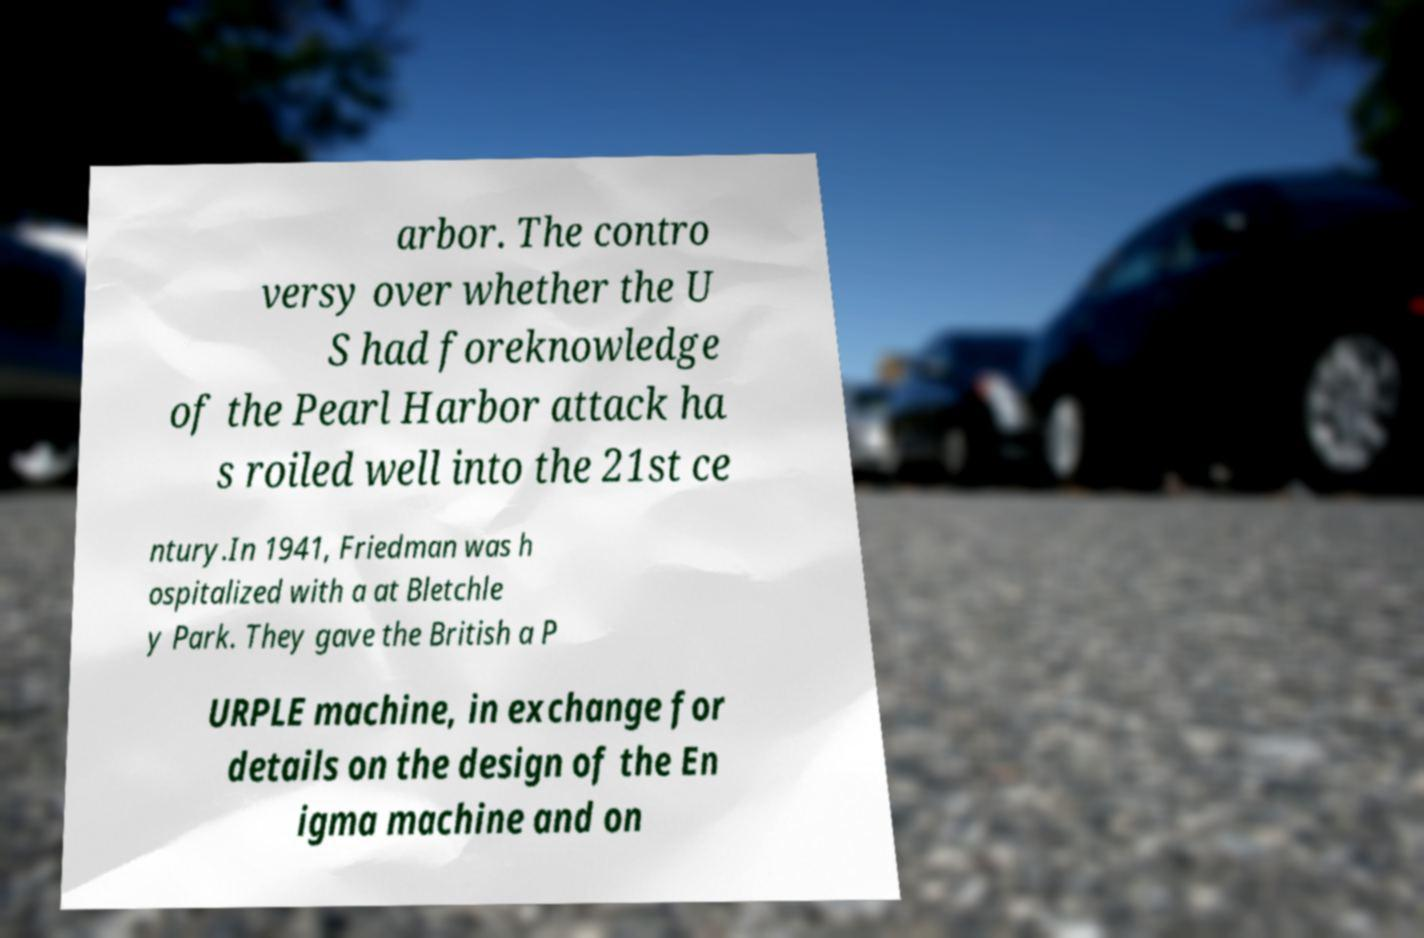Please read and relay the text visible in this image. What does it say? arbor. The contro versy over whether the U S had foreknowledge of the Pearl Harbor attack ha s roiled well into the 21st ce ntury.In 1941, Friedman was h ospitalized with a at Bletchle y Park. They gave the British a P URPLE machine, in exchange for details on the design of the En igma machine and on 